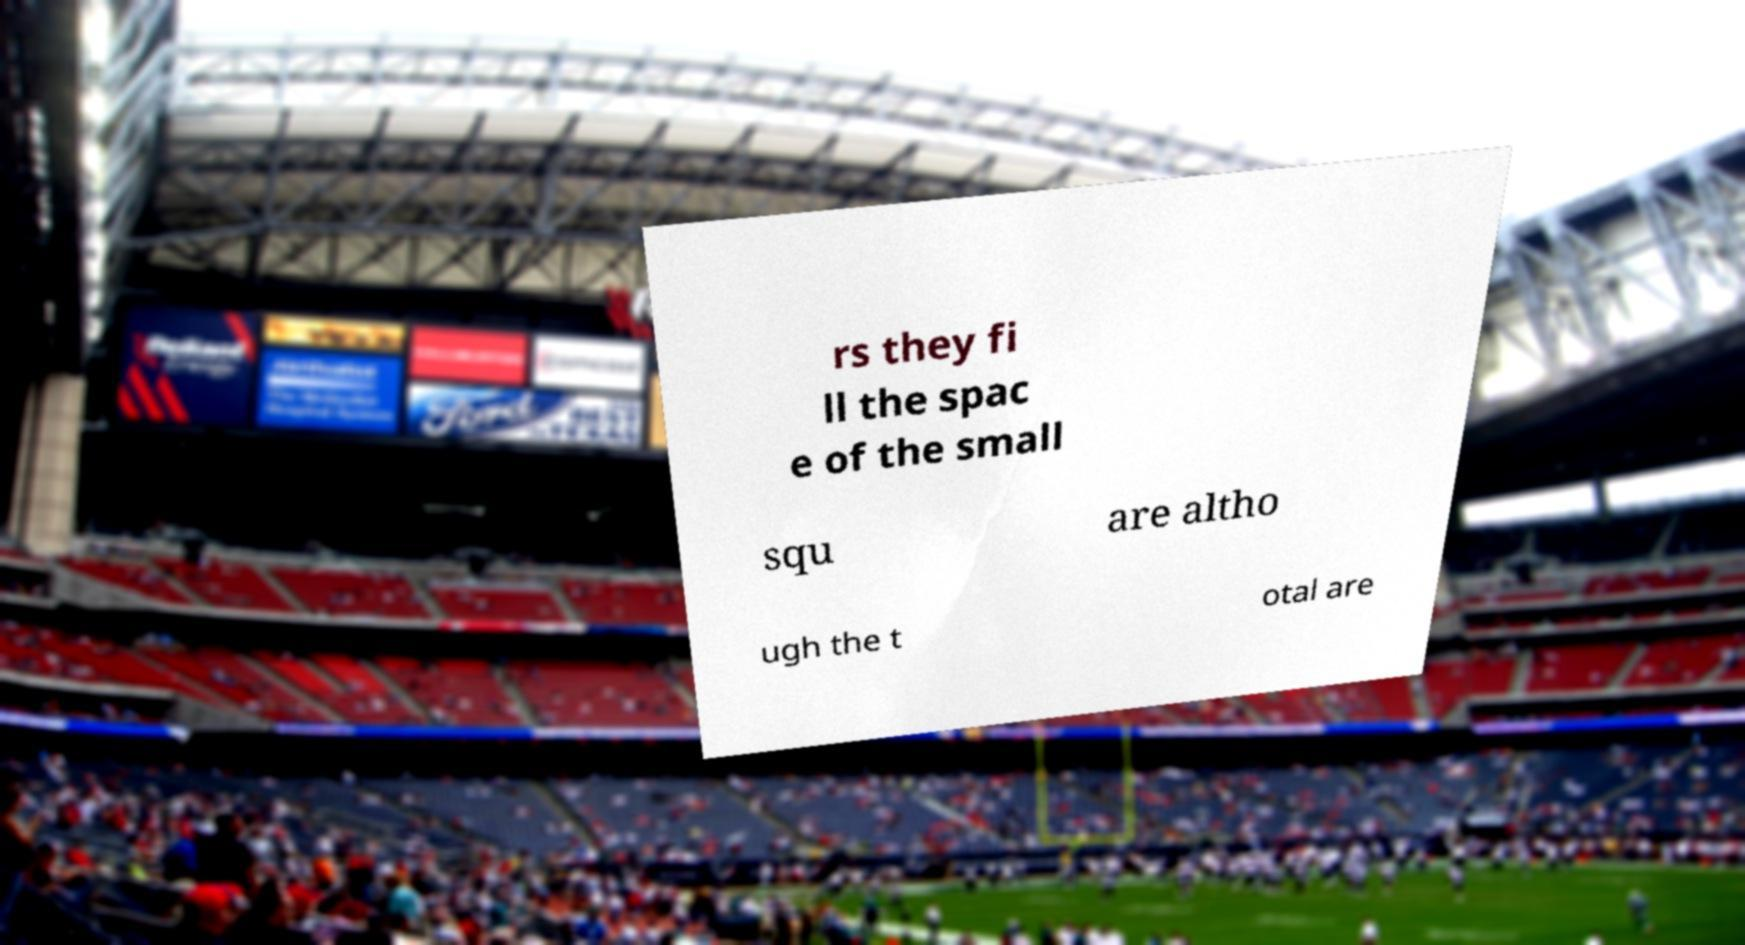There's text embedded in this image that I need extracted. Can you transcribe it verbatim? rs they fi ll the spac e of the small squ are altho ugh the t otal are 